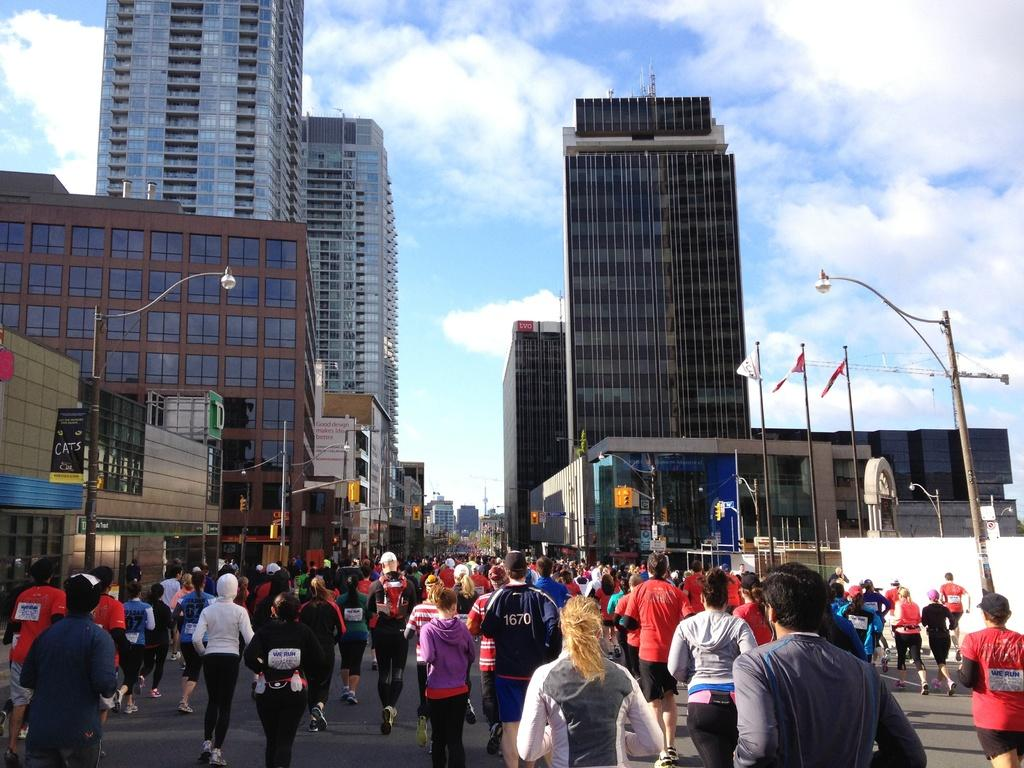How many people are in the image? There are many people in the image. What are the people doing in the image? The people are running on the road. What can be seen on either side of the road in the image? There are buildings on either side of the road. What event might be taking place in the image? It appears to be a marathon. What is visible in the sky in the image? The sky is visible in the image, and there are clouds in the sky. What type of furniture can be seen in the image? There is no furniture present in the image; it features people running on the road with buildings in the background. Can you tell me how many airplanes are visible in the image? There are no airplanes visible in the image; it focuses on people running on the road and the surrounding buildings. 